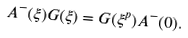<formula> <loc_0><loc_0><loc_500><loc_500>A ^ { - } ( \xi ) G ( \xi ) = G ( \xi ^ { p } ) A ^ { - } ( 0 ) .</formula> 